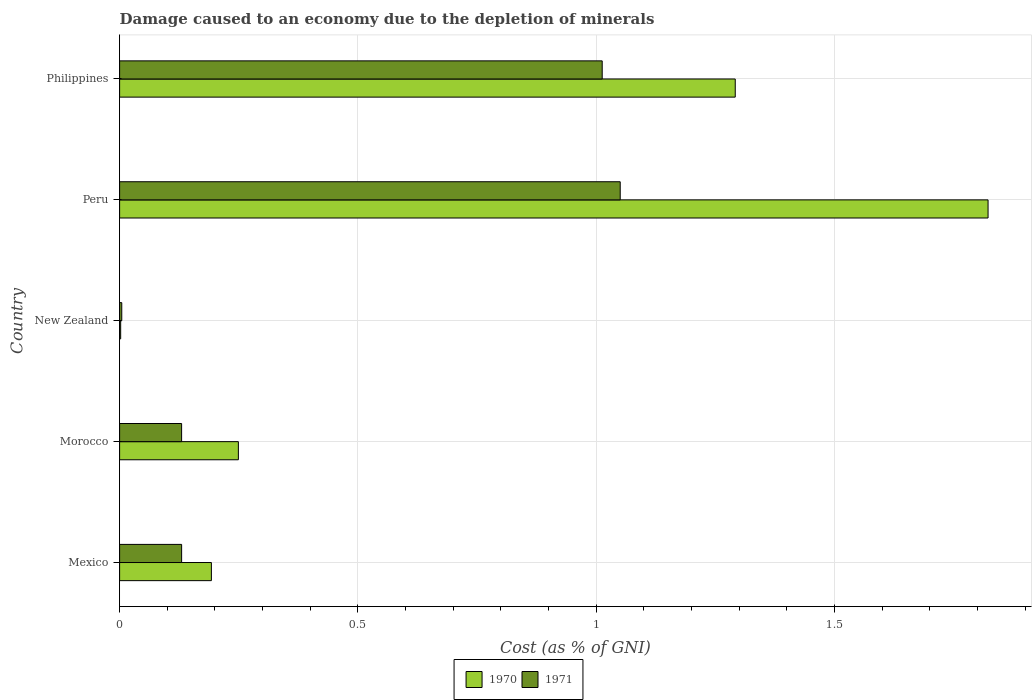Are the number of bars on each tick of the Y-axis equal?
Provide a short and direct response. Yes. How many bars are there on the 5th tick from the bottom?
Make the answer very short. 2. What is the label of the 4th group of bars from the top?
Make the answer very short. Morocco. In how many cases, is the number of bars for a given country not equal to the number of legend labels?
Your answer should be very brief. 0. What is the cost of damage caused due to the depletion of minerals in 1970 in Philippines?
Your answer should be very brief. 1.29. Across all countries, what is the maximum cost of damage caused due to the depletion of minerals in 1970?
Make the answer very short. 1.82. Across all countries, what is the minimum cost of damage caused due to the depletion of minerals in 1971?
Offer a very short reply. 0. In which country was the cost of damage caused due to the depletion of minerals in 1970 maximum?
Offer a terse response. Peru. In which country was the cost of damage caused due to the depletion of minerals in 1970 minimum?
Keep it short and to the point. New Zealand. What is the total cost of damage caused due to the depletion of minerals in 1970 in the graph?
Your answer should be compact. 3.56. What is the difference between the cost of damage caused due to the depletion of minerals in 1971 in Mexico and that in Philippines?
Give a very brief answer. -0.88. What is the difference between the cost of damage caused due to the depletion of minerals in 1971 in New Zealand and the cost of damage caused due to the depletion of minerals in 1970 in Morocco?
Make the answer very short. -0.24. What is the average cost of damage caused due to the depletion of minerals in 1971 per country?
Provide a short and direct response. 0.47. What is the difference between the cost of damage caused due to the depletion of minerals in 1971 and cost of damage caused due to the depletion of minerals in 1970 in New Zealand?
Offer a very short reply. 0. In how many countries, is the cost of damage caused due to the depletion of minerals in 1971 greater than 1.7 %?
Provide a succinct answer. 0. What is the ratio of the cost of damage caused due to the depletion of minerals in 1970 in New Zealand to that in Philippines?
Give a very brief answer. 0. Is the cost of damage caused due to the depletion of minerals in 1970 in Morocco less than that in New Zealand?
Your answer should be compact. No. Is the difference between the cost of damage caused due to the depletion of minerals in 1971 in Mexico and New Zealand greater than the difference between the cost of damage caused due to the depletion of minerals in 1970 in Mexico and New Zealand?
Ensure brevity in your answer.  No. What is the difference between the highest and the second highest cost of damage caused due to the depletion of minerals in 1970?
Ensure brevity in your answer.  0.53. What is the difference between the highest and the lowest cost of damage caused due to the depletion of minerals in 1971?
Your response must be concise. 1.05. Is the sum of the cost of damage caused due to the depletion of minerals in 1971 in Mexico and Peru greater than the maximum cost of damage caused due to the depletion of minerals in 1970 across all countries?
Your answer should be very brief. No. What does the 2nd bar from the top in Mexico represents?
Provide a short and direct response. 1970. How many bars are there?
Offer a terse response. 10. Does the graph contain any zero values?
Offer a very short reply. No. How many legend labels are there?
Keep it short and to the point. 2. What is the title of the graph?
Your answer should be very brief. Damage caused to an economy due to the depletion of minerals. What is the label or title of the X-axis?
Your response must be concise. Cost (as % of GNI). What is the label or title of the Y-axis?
Offer a very short reply. Country. What is the Cost (as % of GNI) in 1970 in Mexico?
Your response must be concise. 0.19. What is the Cost (as % of GNI) of 1971 in Mexico?
Provide a succinct answer. 0.13. What is the Cost (as % of GNI) in 1970 in Morocco?
Provide a short and direct response. 0.25. What is the Cost (as % of GNI) of 1971 in Morocco?
Offer a terse response. 0.13. What is the Cost (as % of GNI) in 1970 in New Zealand?
Provide a succinct answer. 0. What is the Cost (as % of GNI) of 1971 in New Zealand?
Your response must be concise. 0. What is the Cost (as % of GNI) in 1970 in Peru?
Your answer should be compact. 1.82. What is the Cost (as % of GNI) of 1971 in Peru?
Your response must be concise. 1.05. What is the Cost (as % of GNI) of 1970 in Philippines?
Make the answer very short. 1.29. What is the Cost (as % of GNI) in 1971 in Philippines?
Ensure brevity in your answer.  1.01. Across all countries, what is the maximum Cost (as % of GNI) in 1970?
Provide a succinct answer. 1.82. Across all countries, what is the maximum Cost (as % of GNI) of 1971?
Provide a short and direct response. 1.05. Across all countries, what is the minimum Cost (as % of GNI) of 1970?
Provide a short and direct response. 0. Across all countries, what is the minimum Cost (as % of GNI) of 1971?
Keep it short and to the point. 0. What is the total Cost (as % of GNI) in 1970 in the graph?
Your answer should be compact. 3.56. What is the total Cost (as % of GNI) of 1971 in the graph?
Your answer should be compact. 2.33. What is the difference between the Cost (as % of GNI) of 1970 in Mexico and that in Morocco?
Offer a terse response. -0.06. What is the difference between the Cost (as % of GNI) in 1970 in Mexico and that in New Zealand?
Your answer should be very brief. 0.19. What is the difference between the Cost (as % of GNI) in 1971 in Mexico and that in New Zealand?
Your answer should be compact. 0.13. What is the difference between the Cost (as % of GNI) in 1970 in Mexico and that in Peru?
Provide a succinct answer. -1.63. What is the difference between the Cost (as % of GNI) in 1971 in Mexico and that in Peru?
Keep it short and to the point. -0.92. What is the difference between the Cost (as % of GNI) in 1970 in Mexico and that in Philippines?
Offer a very short reply. -1.1. What is the difference between the Cost (as % of GNI) of 1971 in Mexico and that in Philippines?
Offer a terse response. -0.88. What is the difference between the Cost (as % of GNI) in 1970 in Morocco and that in New Zealand?
Offer a terse response. 0.25. What is the difference between the Cost (as % of GNI) of 1971 in Morocco and that in New Zealand?
Provide a succinct answer. 0.13. What is the difference between the Cost (as % of GNI) in 1970 in Morocco and that in Peru?
Make the answer very short. -1.57. What is the difference between the Cost (as % of GNI) of 1971 in Morocco and that in Peru?
Offer a very short reply. -0.92. What is the difference between the Cost (as % of GNI) of 1970 in Morocco and that in Philippines?
Ensure brevity in your answer.  -1.04. What is the difference between the Cost (as % of GNI) of 1971 in Morocco and that in Philippines?
Offer a terse response. -0.88. What is the difference between the Cost (as % of GNI) in 1970 in New Zealand and that in Peru?
Give a very brief answer. -1.82. What is the difference between the Cost (as % of GNI) in 1971 in New Zealand and that in Peru?
Your response must be concise. -1.05. What is the difference between the Cost (as % of GNI) of 1970 in New Zealand and that in Philippines?
Provide a short and direct response. -1.29. What is the difference between the Cost (as % of GNI) of 1971 in New Zealand and that in Philippines?
Ensure brevity in your answer.  -1.01. What is the difference between the Cost (as % of GNI) in 1970 in Peru and that in Philippines?
Provide a short and direct response. 0.53. What is the difference between the Cost (as % of GNI) of 1971 in Peru and that in Philippines?
Your answer should be compact. 0.04. What is the difference between the Cost (as % of GNI) of 1970 in Mexico and the Cost (as % of GNI) of 1971 in Morocco?
Provide a succinct answer. 0.06. What is the difference between the Cost (as % of GNI) of 1970 in Mexico and the Cost (as % of GNI) of 1971 in New Zealand?
Offer a terse response. 0.19. What is the difference between the Cost (as % of GNI) of 1970 in Mexico and the Cost (as % of GNI) of 1971 in Peru?
Your answer should be very brief. -0.86. What is the difference between the Cost (as % of GNI) in 1970 in Mexico and the Cost (as % of GNI) in 1971 in Philippines?
Your response must be concise. -0.82. What is the difference between the Cost (as % of GNI) in 1970 in Morocco and the Cost (as % of GNI) in 1971 in New Zealand?
Offer a terse response. 0.24. What is the difference between the Cost (as % of GNI) of 1970 in Morocco and the Cost (as % of GNI) of 1971 in Peru?
Offer a terse response. -0.8. What is the difference between the Cost (as % of GNI) in 1970 in Morocco and the Cost (as % of GNI) in 1971 in Philippines?
Offer a terse response. -0.76. What is the difference between the Cost (as % of GNI) in 1970 in New Zealand and the Cost (as % of GNI) in 1971 in Peru?
Keep it short and to the point. -1.05. What is the difference between the Cost (as % of GNI) of 1970 in New Zealand and the Cost (as % of GNI) of 1971 in Philippines?
Give a very brief answer. -1.01. What is the difference between the Cost (as % of GNI) in 1970 in Peru and the Cost (as % of GNI) in 1971 in Philippines?
Provide a succinct answer. 0.81. What is the average Cost (as % of GNI) in 1970 per country?
Ensure brevity in your answer.  0.71. What is the average Cost (as % of GNI) of 1971 per country?
Give a very brief answer. 0.47. What is the difference between the Cost (as % of GNI) of 1970 and Cost (as % of GNI) of 1971 in Mexico?
Give a very brief answer. 0.06. What is the difference between the Cost (as % of GNI) in 1970 and Cost (as % of GNI) in 1971 in Morocco?
Your answer should be very brief. 0.12. What is the difference between the Cost (as % of GNI) of 1970 and Cost (as % of GNI) of 1971 in New Zealand?
Your answer should be very brief. -0. What is the difference between the Cost (as % of GNI) in 1970 and Cost (as % of GNI) in 1971 in Peru?
Provide a short and direct response. 0.77. What is the difference between the Cost (as % of GNI) in 1970 and Cost (as % of GNI) in 1971 in Philippines?
Provide a succinct answer. 0.28. What is the ratio of the Cost (as % of GNI) of 1970 in Mexico to that in Morocco?
Your answer should be compact. 0.77. What is the ratio of the Cost (as % of GNI) in 1970 in Mexico to that in New Zealand?
Your answer should be compact. 86.15. What is the ratio of the Cost (as % of GNI) of 1971 in Mexico to that in New Zealand?
Your answer should be compact. 28.66. What is the ratio of the Cost (as % of GNI) in 1970 in Mexico to that in Peru?
Give a very brief answer. 0.11. What is the ratio of the Cost (as % of GNI) of 1971 in Mexico to that in Peru?
Ensure brevity in your answer.  0.12. What is the ratio of the Cost (as % of GNI) of 1970 in Mexico to that in Philippines?
Ensure brevity in your answer.  0.15. What is the ratio of the Cost (as % of GNI) of 1971 in Mexico to that in Philippines?
Offer a terse response. 0.13. What is the ratio of the Cost (as % of GNI) in 1970 in Morocco to that in New Zealand?
Offer a terse response. 111.49. What is the ratio of the Cost (as % of GNI) in 1971 in Morocco to that in New Zealand?
Your answer should be very brief. 28.64. What is the ratio of the Cost (as % of GNI) of 1970 in Morocco to that in Peru?
Your response must be concise. 0.14. What is the ratio of the Cost (as % of GNI) of 1971 in Morocco to that in Peru?
Your answer should be compact. 0.12. What is the ratio of the Cost (as % of GNI) of 1970 in Morocco to that in Philippines?
Offer a very short reply. 0.19. What is the ratio of the Cost (as % of GNI) of 1971 in Morocco to that in Philippines?
Provide a succinct answer. 0.13. What is the ratio of the Cost (as % of GNI) of 1970 in New Zealand to that in Peru?
Provide a succinct answer. 0. What is the ratio of the Cost (as % of GNI) of 1971 in New Zealand to that in Peru?
Give a very brief answer. 0. What is the ratio of the Cost (as % of GNI) of 1970 in New Zealand to that in Philippines?
Give a very brief answer. 0. What is the ratio of the Cost (as % of GNI) of 1971 in New Zealand to that in Philippines?
Your answer should be compact. 0. What is the ratio of the Cost (as % of GNI) of 1970 in Peru to that in Philippines?
Offer a very short reply. 1.41. What is the ratio of the Cost (as % of GNI) of 1971 in Peru to that in Philippines?
Give a very brief answer. 1.04. What is the difference between the highest and the second highest Cost (as % of GNI) in 1970?
Provide a short and direct response. 0.53. What is the difference between the highest and the second highest Cost (as % of GNI) in 1971?
Keep it short and to the point. 0.04. What is the difference between the highest and the lowest Cost (as % of GNI) of 1970?
Ensure brevity in your answer.  1.82. What is the difference between the highest and the lowest Cost (as % of GNI) of 1971?
Your answer should be very brief. 1.05. 